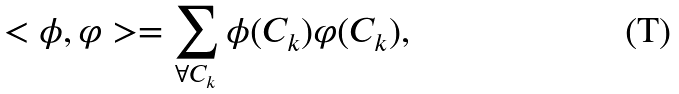<formula> <loc_0><loc_0><loc_500><loc_500>< \phi , \varphi > = \sum _ { \forall C _ { k } } \phi ( C _ { k } ) \varphi ( C _ { k } ) ,</formula> 